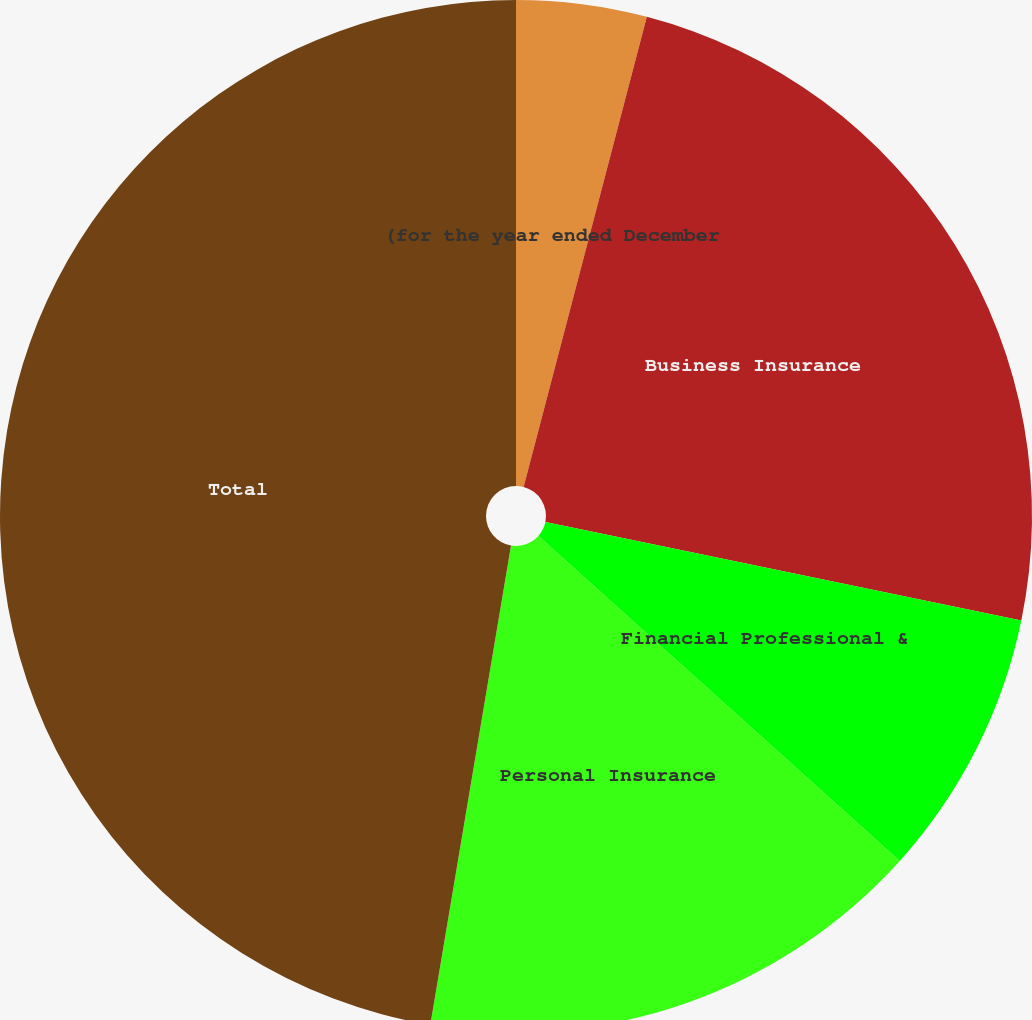<chart> <loc_0><loc_0><loc_500><loc_500><pie_chart><fcel>(for the year ended December<fcel>Business Insurance<fcel>Financial Professional &<fcel>Personal Insurance<fcel>Total<nl><fcel>4.08%<fcel>24.16%<fcel>8.41%<fcel>16.0%<fcel>47.34%<nl></chart> 